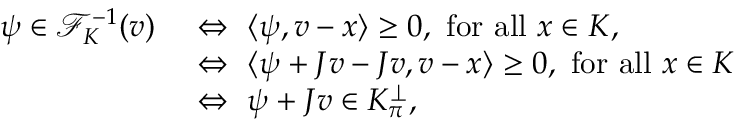<formula> <loc_0><loc_0><loc_500><loc_500>\begin{array} { r l } { \psi \in \mathcal { F } _ { K } ^ { - 1 } ( v ) \ } & { \Leftrightarrow \ \langle \psi , v - x \rangle \geq 0 , \ f o r a l l \ x \in K , } \\ & { \Leftrightarrow \ \langle \psi + J v - J v , v - x \rangle \geq 0 , \ f o r a l l \ x \in K } \\ & { \Leftrightarrow \ \psi + J v \in K _ { \pi } ^ { \perp } , } \end{array}</formula> 